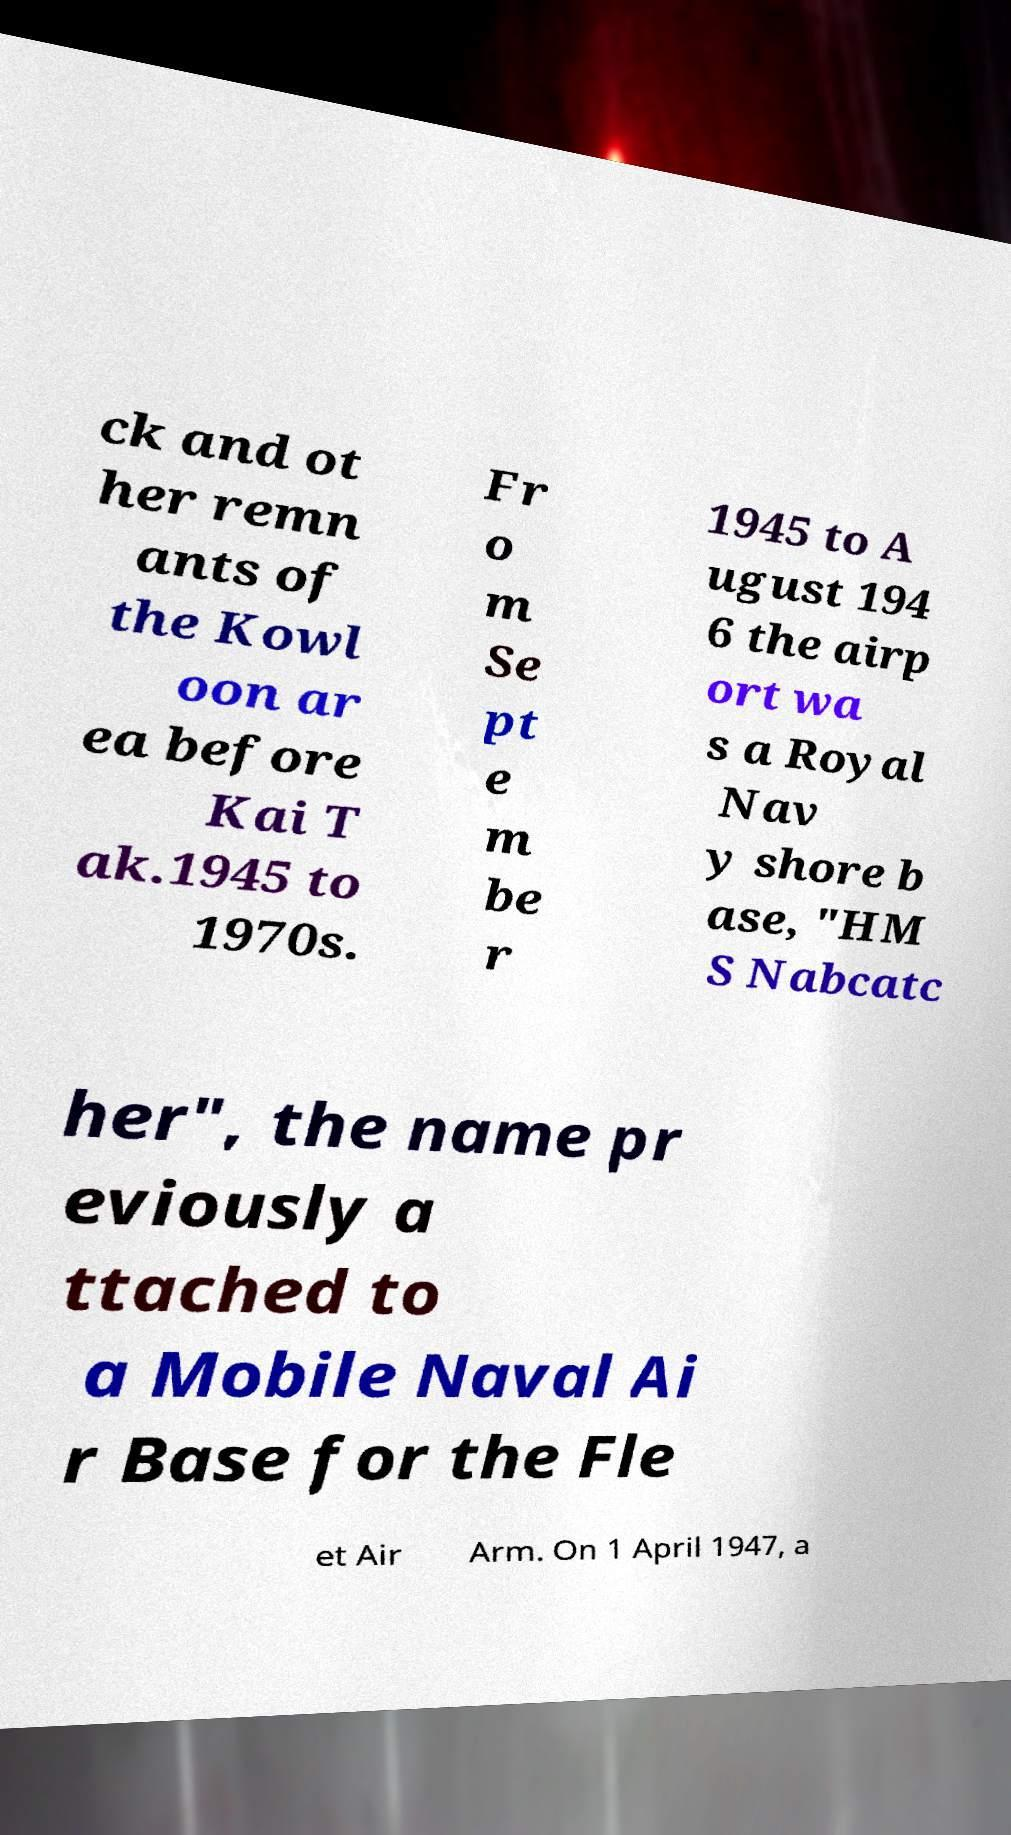For documentation purposes, I need the text within this image transcribed. Could you provide that? ck and ot her remn ants of the Kowl oon ar ea before Kai T ak.1945 to 1970s. Fr o m Se pt e m be r 1945 to A ugust 194 6 the airp ort wa s a Royal Nav y shore b ase, "HM S Nabcatc her", the name pr eviously a ttached to a Mobile Naval Ai r Base for the Fle et Air Arm. On 1 April 1947, a 